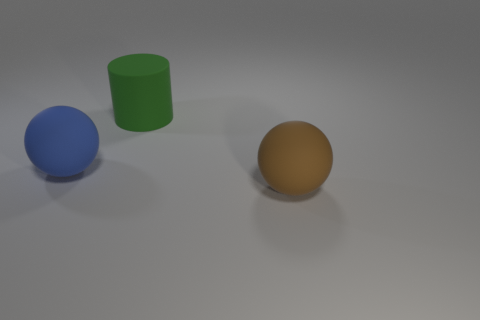Subtract all blue balls. How many balls are left? 1 Add 1 large brown objects. How many objects exist? 4 Subtract all cylinders. How many objects are left? 2 Add 2 blue rubber objects. How many blue rubber objects are left? 3 Add 3 large blue matte balls. How many large blue matte balls exist? 4 Subtract 0 green spheres. How many objects are left? 3 Subtract all yellow cylinders. Subtract all gray balls. How many cylinders are left? 1 Subtract all red cylinders. How many green balls are left? 0 Subtract all purple cylinders. Subtract all large rubber spheres. How many objects are left? 1 